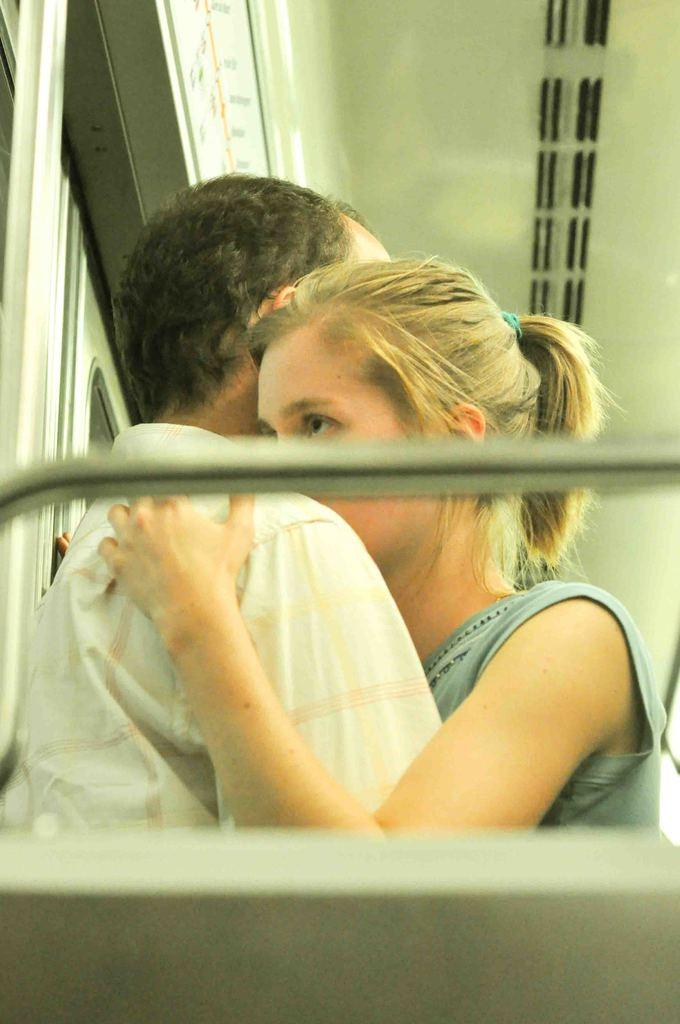What is the setting of the image? The image is taken in a train. What are the people in the image doing? There is a man and a lady hugging each other in the center of the image. What can be seen on the left side of the image? There is a window on the left side of the image. Can you hear the goldfish swimming in the image? There are no goldfish present in the image, so it is not possible to hear them swimming. What type of rifle is visible in the image? There is no rifle present in the image. 